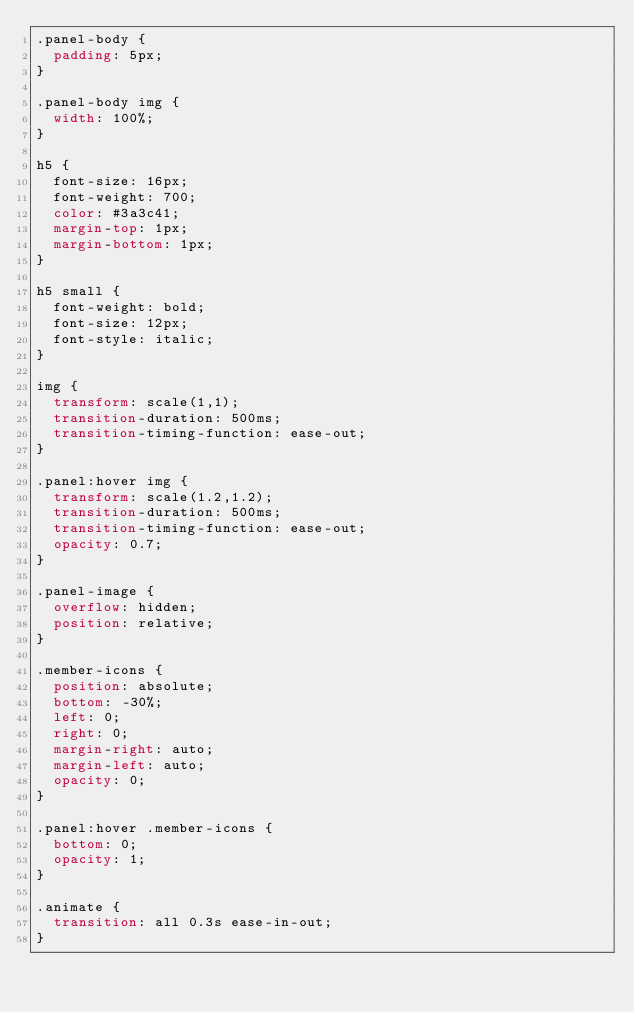Convert code to text. <code><loc_0><loc_0><loc_500><loc_500><_CSS_>.panel-body {
  padding: 5px;
}

.panel-body img {
  width: 100%;
}

h5 {
  font-size: 16px;
  font-weight: 700;
  color: #3a3c41;
  margin-top: 1px;
  margin-bottom: 1px;
}

h5 small {
  font-weight: bold;
  font-size: 12px;
  font-style: italic;
}

img {
  transform: scale(1,1);
  transition-duration: 500ms;
  transition-timing-function: ease-out;
}

.panel:hover img {
  transform: scale(1.2,1.2);
  transition-duration: 500ms;
  transition-timing-function: ease-out;
  opacity: 0.7;
}

.panel-image {
  overflow: hidden;
  position: relative;
}

.member-icons {
  position: absolute;
  bottom: -30%;
  left: 0;
  right: 0;
  margin-right: auto;
  margin-left: auto;
  opacity: 0;
}

.panel:hover .member-icons {
  bottom: 0;
  opacity: 1;
}

.animate {
  transition: all 0.3s ease-in-out;
}
</code> 